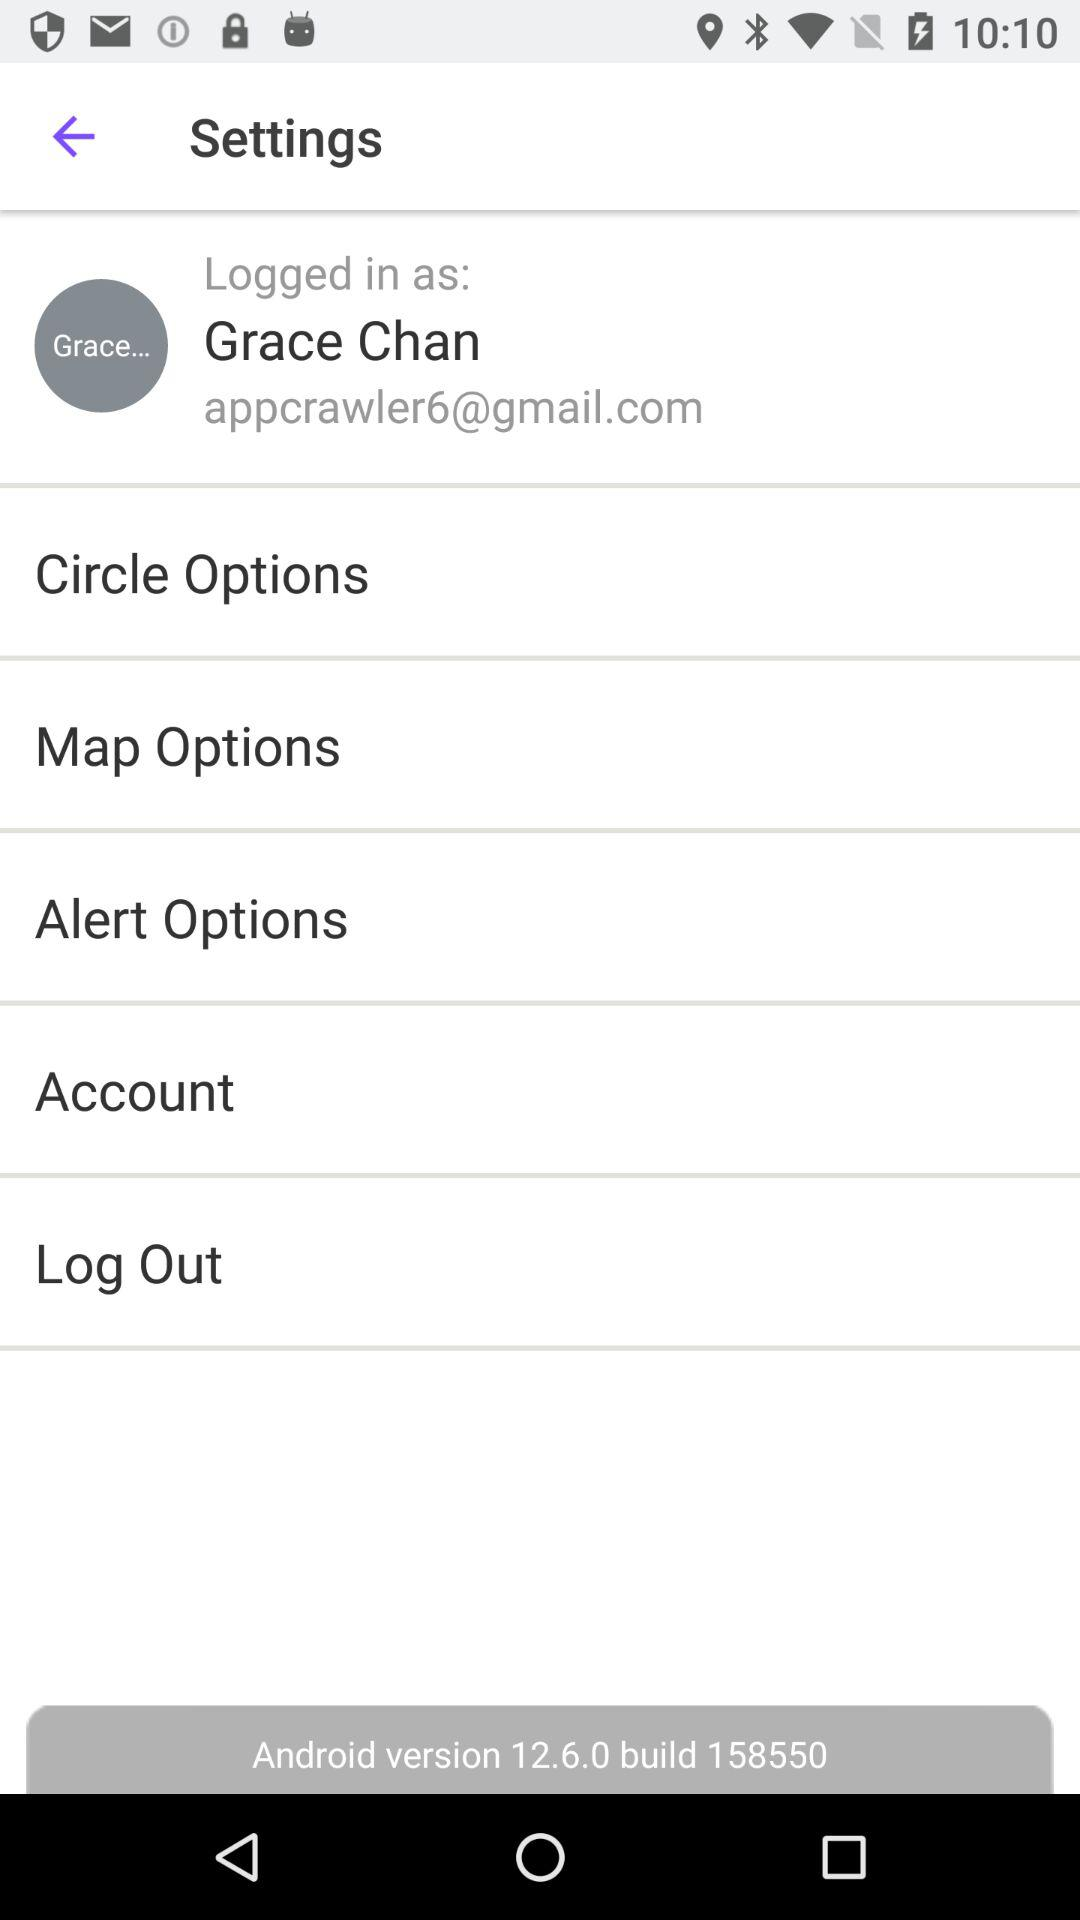What is the Android version? The Android version is 12.6.0. 